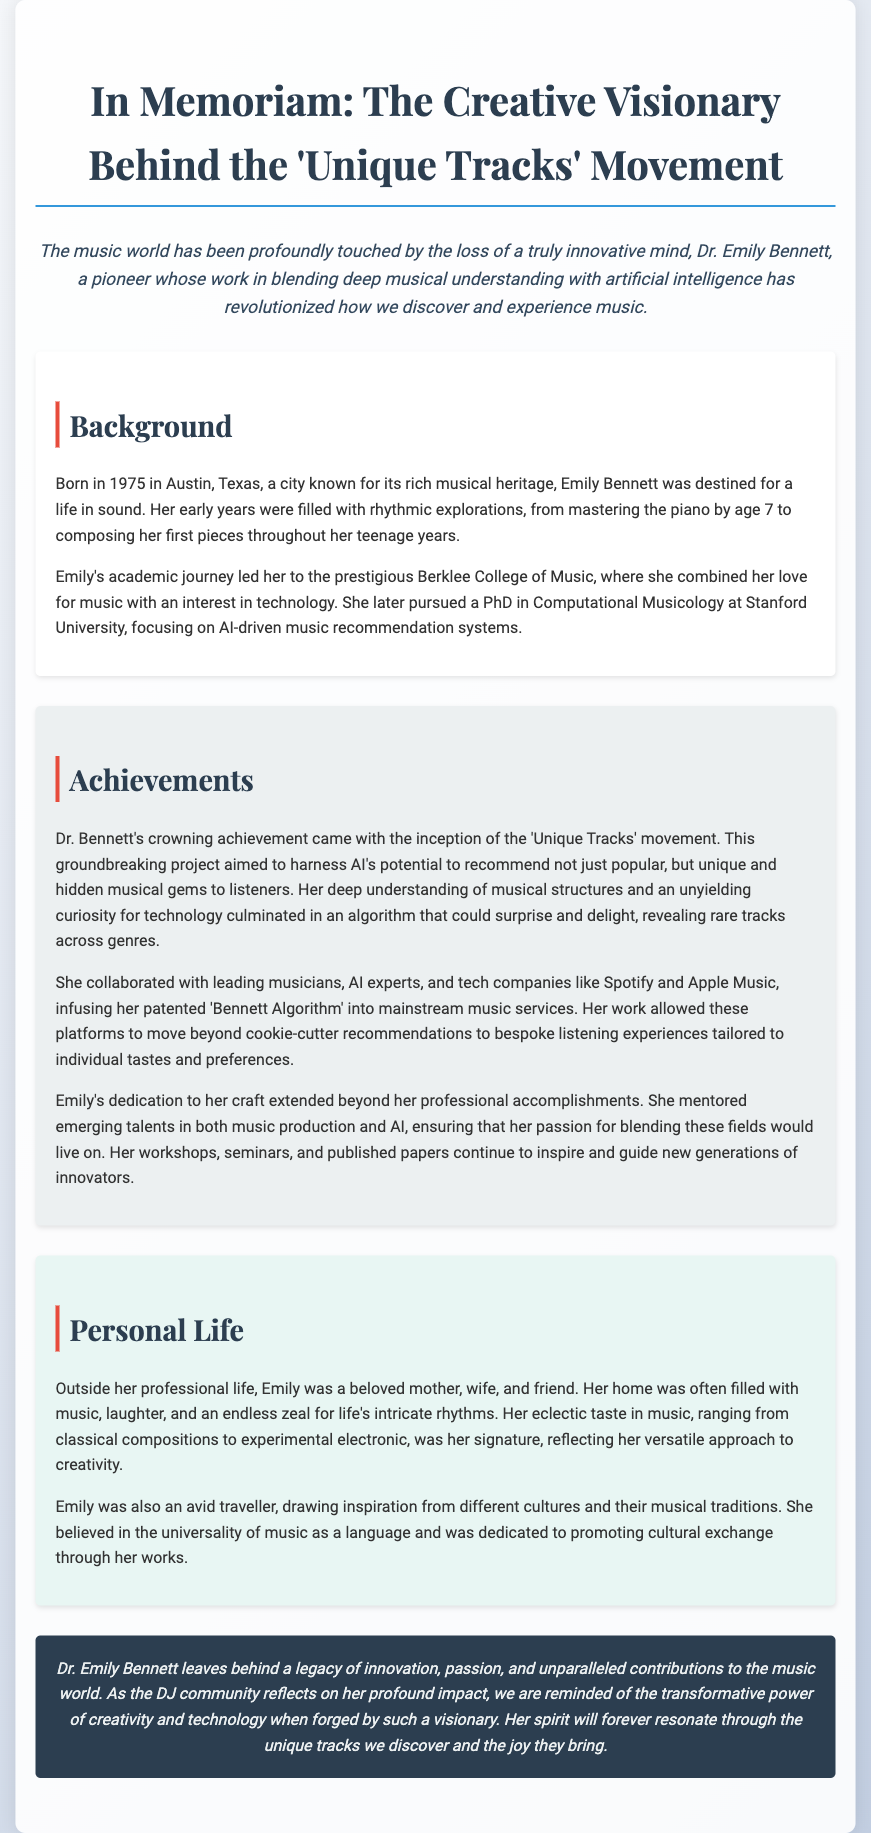What year was Dr. Emily Bennett born? The document states that Dr. Emily Bennett was born in 1975.
Answer: 1975 What was Emily's PhD focus? The document indicates that she focused on AI-driven music recommendation systems for her PhD in Computational Musicology.
Answer: AI-driven music recommendation systems What movement did Emily Bennett create? The document mentions that Emily was the creative force behind the 'Unique Tracks' movement.
Answer: Unique Tracks How did Emily's algorithm change music recommendation? The document explains that her algorithm allowed platforms to move beyond cookie-cutter recommendations to bespoke listening experiences.
Answer: Bespoke listening experiences Who did Emily collaborate with? The document lists collaborations with leading musicians, AI experts, and tech companies like Spotify and Apple Music.
Answer: Musicians, AI experts, Spotify, Apple Music What was Emily's contribution to music platforms? The document states that she infused her patented 'Bennett Algorithm' into mainstream music services.
Answer: Bennett Algorithm What is noted about Emily's travel habits? The document describes her as an avid traveller drawing inspiration from different cultures.
Answer: Avid traveller What legacy did Dr. Emily Bennett leave behind? The document concludes with noting her legacy of innovation, passion, and unparalleled contributions to the music world.
Answer: Innovation, passion, contributions 